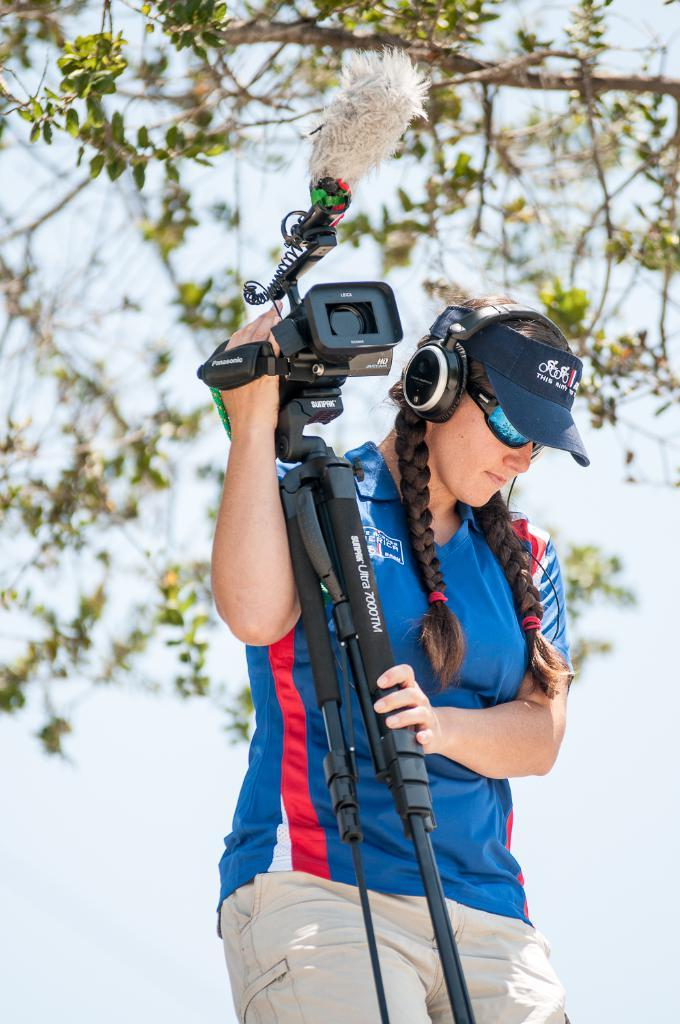What color is the t-shirt worn by the person in the image? The person in the image is wearing a blue t-shirt. What is the person holding in the image? The person is holding a camera. What type of audio equipment is the person wearing? The person has headphones on. What type of hat is the person wearing? The person is wearing a cap. What type of eyewear is the person wearing? The person is wearing sunglasses. What can be seen in the background of the image? There is a tree in the background of the image. What is the condition of the sky in the image? The sky is clear in the image. How many plants are being limited by the person in the image? There are no plants or any indication of limiting plants in the image. What type of snakes can be seen in the image? There are no snakes present in the image. 